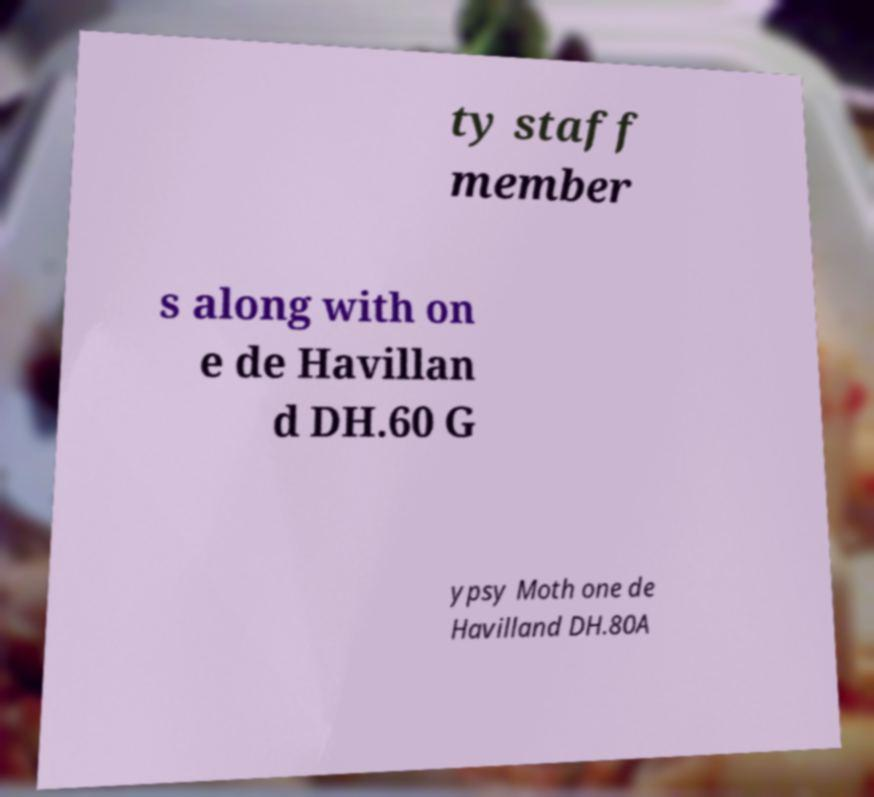Could you extract and type out the text from this image? ty staff member s along with on e de Havillan d DH.60 G ypsy Moth one de Havilland DH.80A 